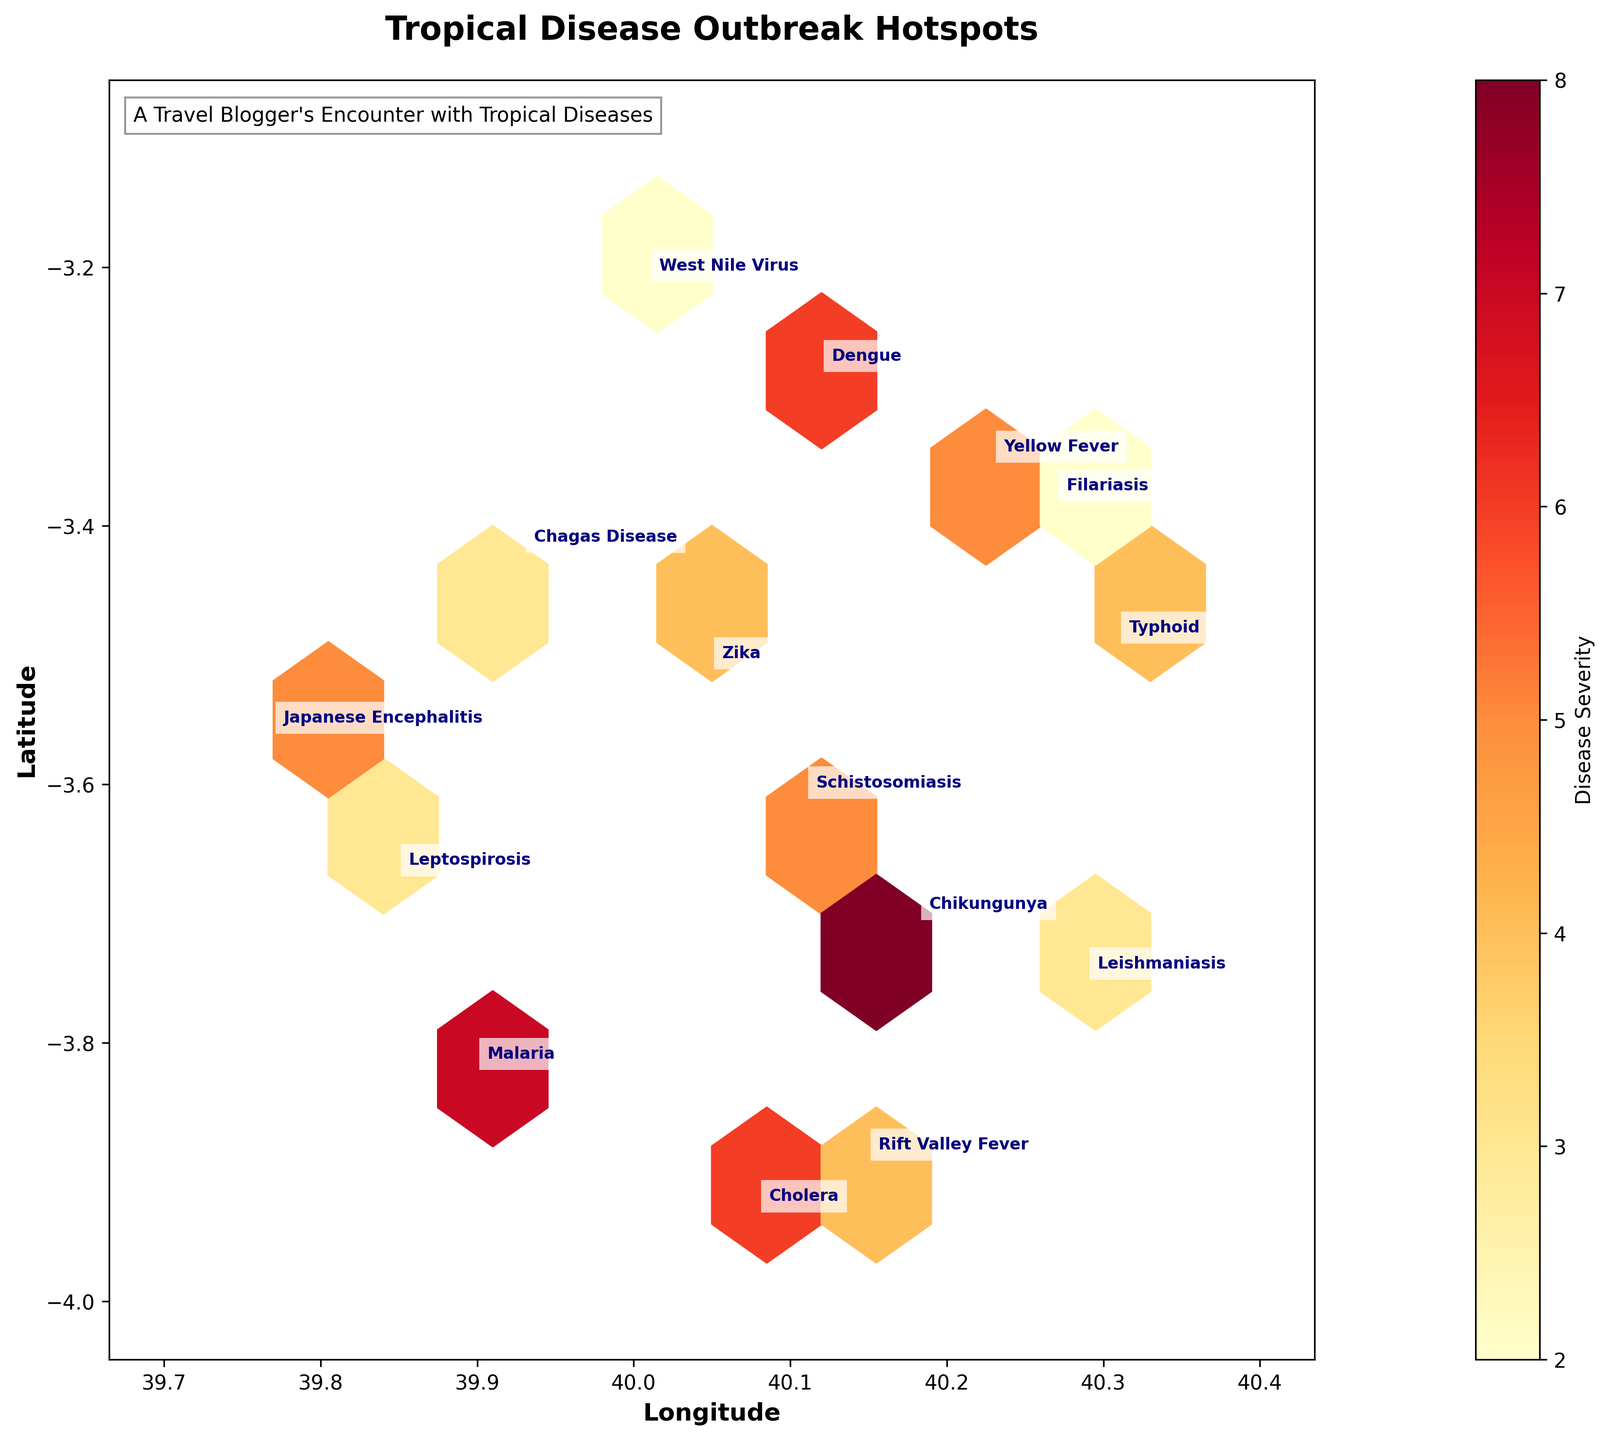What is the title of the hexbin plot? Look at the top section of the plot, you will find the text that describes the overall theme or topic of the plot.
Answer: Tropical Disease Outbreak Hotspots What are the labels for the x-axis and y-axis? On the respective axes, read the text that specifies what each axis represents.
Answer: Longitude and Latitude How are disease severity levels represented in the plot? Refer to the color bar on the side of the plot, which uses a gradient of colors to denote different severity levels.
Answer: By a color gradient ranging from yellow to red Which disease has the highest severity level and where is it located? Find the disease with the highest number next to it and locate its position on the plot.
Answer: Chikungunya at -3.7038 latitude and 40.1824 longitude What is the range of severity levels shown in the plot? Check the minimum and maximum values on the color bar, which represents disease severity.
Answer: From 2 to 8 How does the hexbin plot convey concentration of disease outbreaks? Notice how the density and color intensity of hexagons change; higher concentration areas will show stronger or more dense shading.
Answer: Using hexagonal clusters with color intensity Which area appears to have the most diverse types of disease outbreaks? Look for the region in the hexbin plot where multiple diseases are annotated closely together.
Answer: Around latitude -3.8 and longitude 40.1 If you were to visit the area with Typhoid, what severity should you expect? Locate the annotation for Typhoid and refer to the color and number next to it.
Answer: Severity level 4 Among the diseases Filariasis and Japanese Encephalitis, which one has a higher severity level? Compare the severity numbers annotated next to Filariasis and Japanese Encephalitis.
Answer: Japanese Encephalitis What would be an appropriate message to display alongside the image to indicate its relevance to your travel experience? Referring to the description annotation present in the plot can give an idea of a suitable message that ties back to a personal experience.
Answer: A Travel Blogger's Encounter with Tropical Diseases 